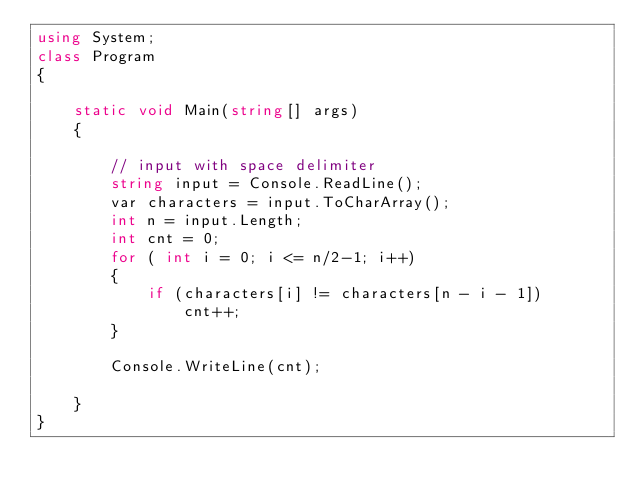<code> <loc_0><loc_0><loc_500><loc_500><_C#_>using System;
class Program
{

    static void Main(string[] args)
    {

        // input with space delimiter
        string input = Console.ReadLine();
        var characters = input.ToCharArray();
        int n = input.Length;
        int cnt = 0;
        for ( int i = 0; i <= n/2-1; i++)
        {
            if (characters[i] != characters[n - i - 1])
                cnt++;
        }

        Console.WriteLine(cnt);

    }
}</code> 